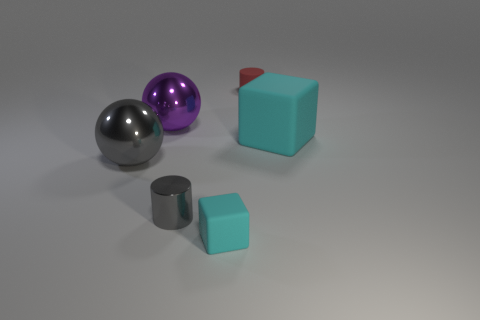Add 1 big cyan matte objects. How many objects exist? 7 Subtract 0 blue cylinders. How many objects are left? 6 Subtract all balls. How many objects are left? 4 Subtract all small red blocks. Subtract all small gray shiny cylinders. How many objects are left? 5 Add 2 tiny gray metal cylinders. How many tiny gray metal cylinders are left? 3 Add 6 small gray metallic cylinders. How many small gray metallic cylinders exist? 7 